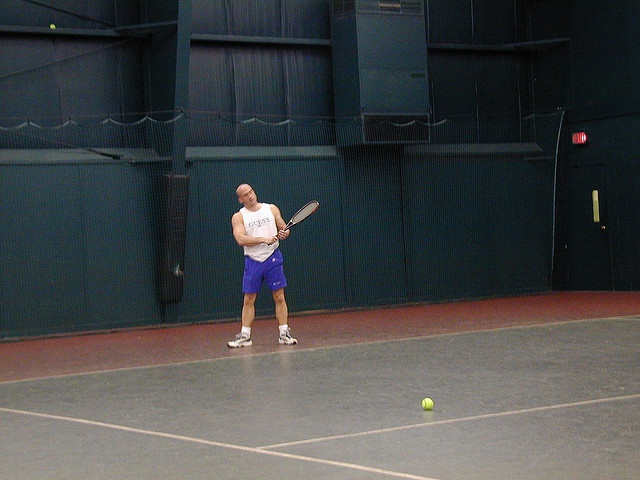Describe the objects in this image and their specific colors. I can see people in black, white, navy, and brown tones, tennis racket in black, darkgray, and gray tones, sports ball in black, khaki, and olive tones, and sports ball in black, khaki, olive, and darkgreen tones in this image. 